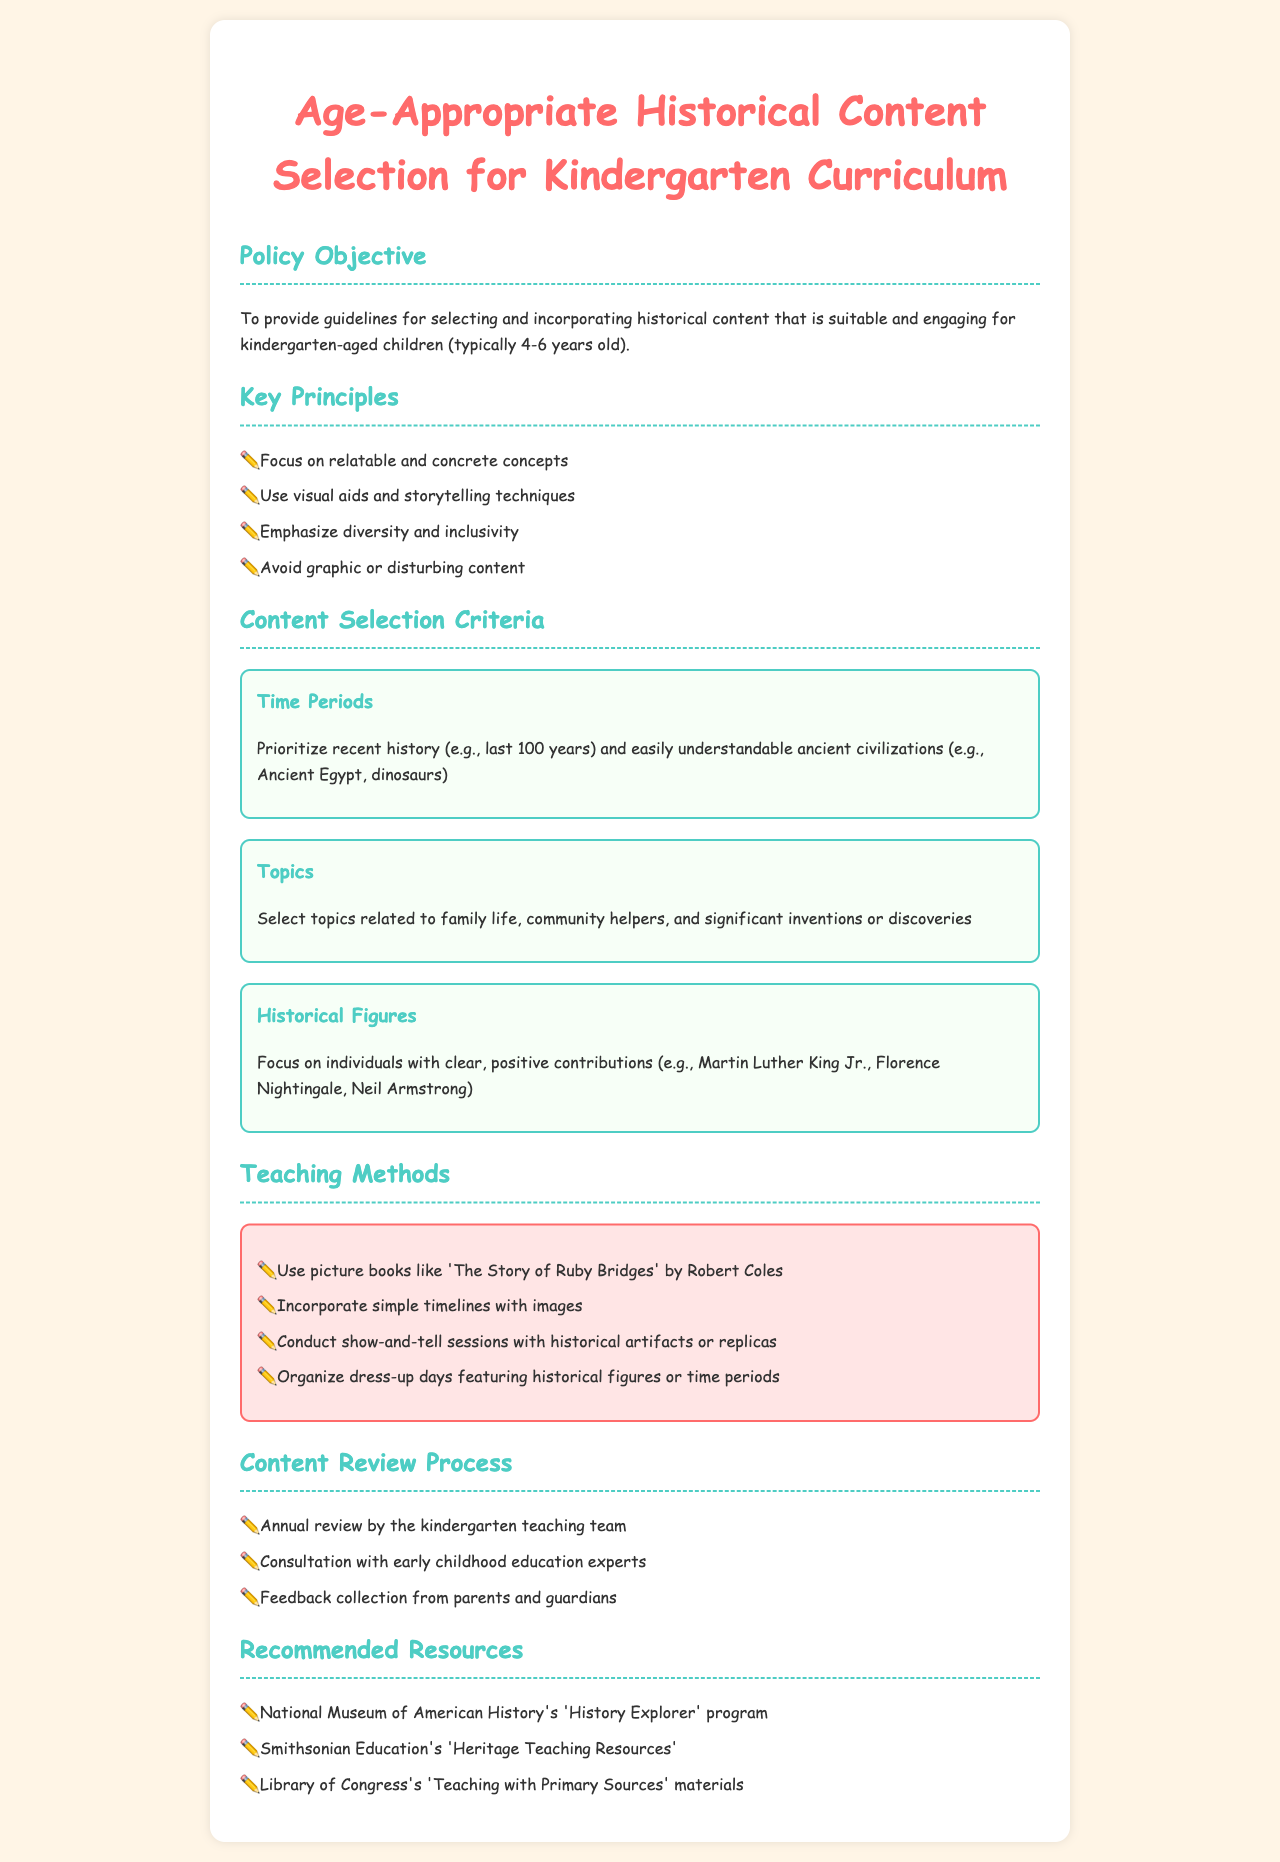What is the aim of the policy? The policy aims to provide guidelines for selecting and incorporating historical content that is suitable and engaging for kindergarten-aged children.
Answer: To provide guidelines for selecting and incorporating historical content What age group does this policy focus on? The policy specifies that it is aimed at children typically aged 4-6 years old.
Answer: 4-6 years old What should the content selection prioritize according to the time periods? The document recommends prioritizing recent history and easily understandable ancient civilizations.
Answer: Recent history and easily understandable ancient civilizations Name one type of teaching method mentioned in the document. One teaching method suggested is to use picture books like 'The Story of Ruby Bridges'.
Answer: Use picture books How often does the content review process take place? The content review process is stated to occur annually by the kindergarten teaching team.
Answer: Annual Which historical figure is highlighted for having a positive contribution? The document mentions Martin Luther King Jr. as an individual with a clear, positive contribution.
Answer: Martin Luther King Jr Which organization’s resources are recommended? The document recommends resources from the National Museum of American History.
Answer: National Museum of American History What is emphasized in the key principles of content selection? The key principles highlight the importance of emphasizing diversity and inclusivity.
Answer: Diversity and inclusivity 